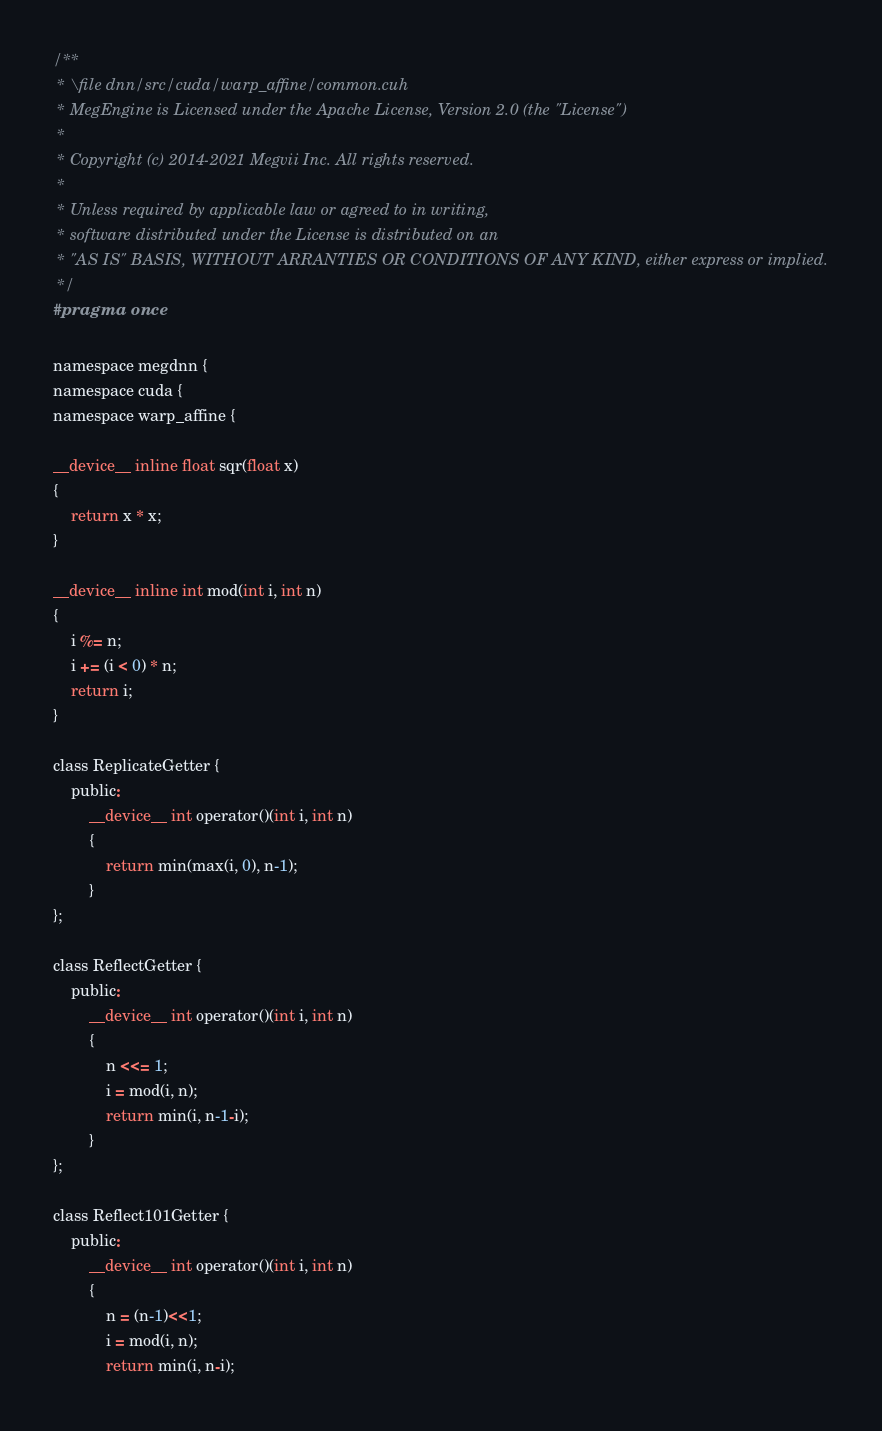Convert code to text. <code><loc_0><loc_0><loc_500><loc_500><_Cuda_>/**
 * \file dnn/src/cuda/warp_affine/common.cuh
 * MegEngine is Licensed under the Apache License, Version 2.0 (the "License")
 *
 * Copyright (c) 2014-2021 Megvii Inc. All rights reserved.
 *
 * Unless required by applicable law or agreed to in writing,
 * software distributed under the License is distributed on an
 * "AS IS" BASIS, WITHOUT ARRANTIES OR CONDITIONS OF ANY KIND, either express or implied.
 */
#pragma once

namespace megdnn {
namespace cuda {
namespace warp_affine {

__device__ inline float sqr(float x)
{
    return x * x;
}

__device__ inline int mod(int i, int n)
{
    i %= n;
    i += (i < 0) * n;
    return i;
}

class ReplicateGetter {
    public:
        __device__ int operator()(int i, int n)
        {
            return min(max(i, 0), n-1);
        }
};

class ReflectGetter {
    public:
        __device__ int operator()(int i, int n)
        {
            n <<= 1;
            i = mod(i, n);
            return min(i, n-1-i);
        }
};

class Reflect101Getter {
    public:
        __device__ int operator()(int i, int n)
        {
            n = (n-1)<<1;
            i = mod(i, n);
            return min(i, n-i);</code> 